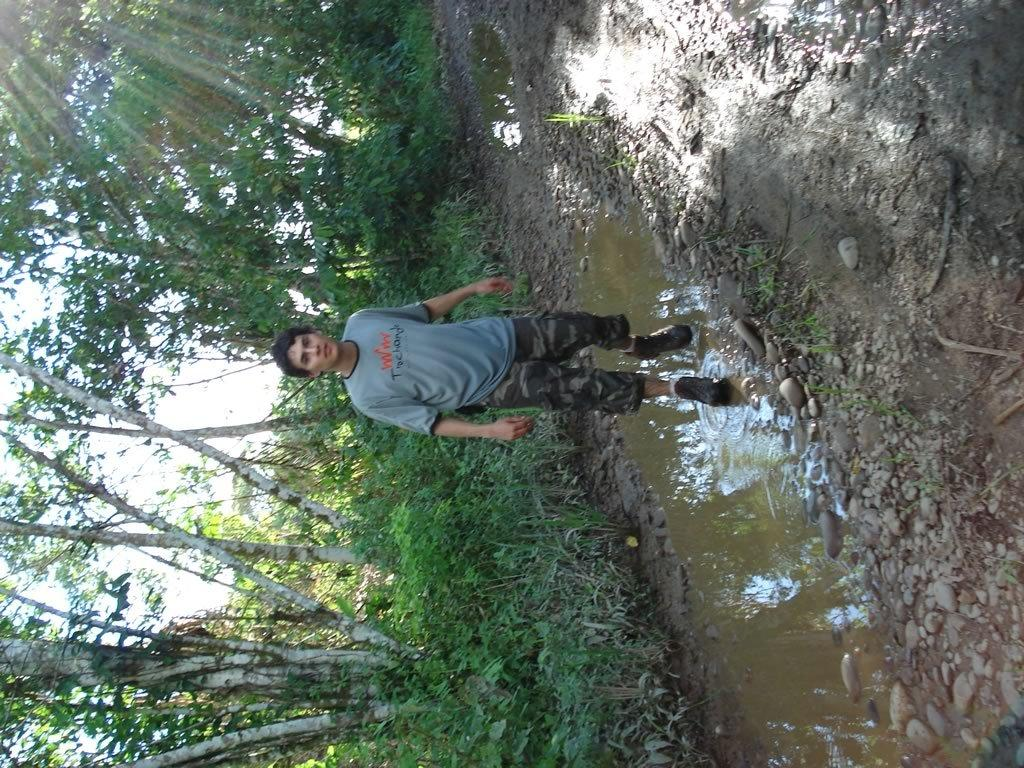What is the person in the image doing? The person is standing in the water. What can be seen in the background of the image? There are trees visible in the background. What is visible at the top of the image? The sky is visible at the top of the image. What is present at the bottom of the image? There are stones at the bottom of the image. What is the primary element in the image? Water is visible in the image. Can you see a sack being carried by the person in the image? There is no sack visible in the image; the person is simply standing in the water. What type of bird can be seen flying in the image? There are no birds present in the image. 